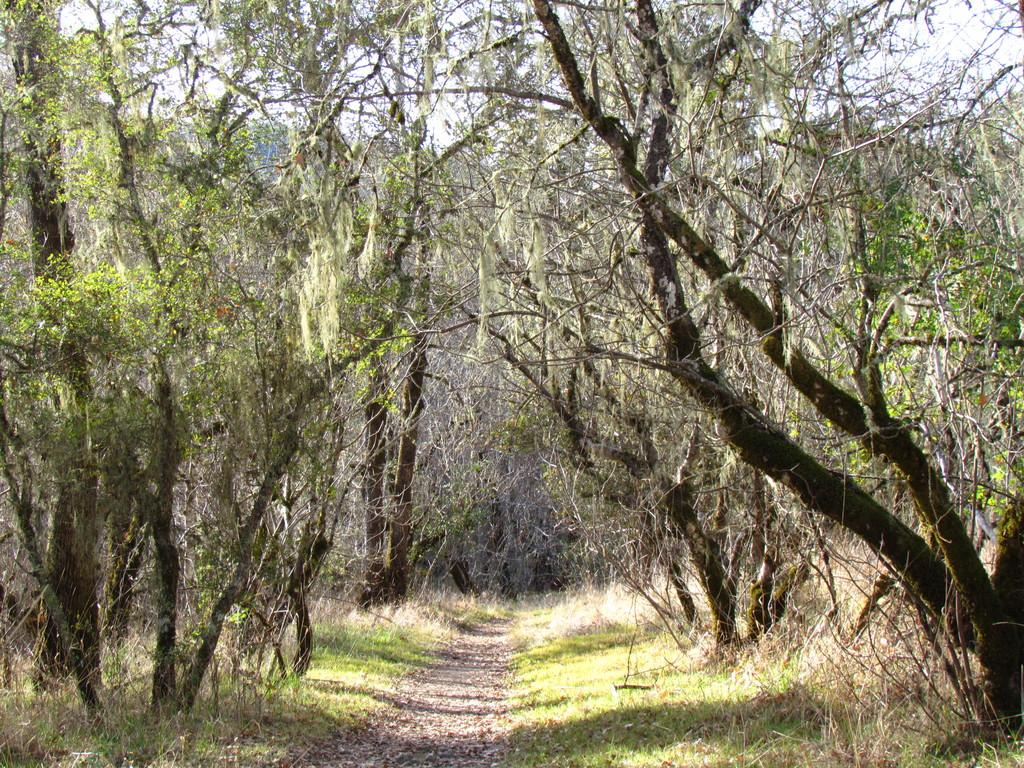What type of vegetation can be seen in the image? There are trees with branches and leaves in the image. What type of ground cover is visible in the image? There is grass visible in the image. Is there any indication of a path or trail in the image? Yes, there appears to be a pathway in the image. Can you describe the location depicted in the image? The location may be a forest, but this is not explicitly stated in the transcript. What is the condition of the yarn in the image? There is no yarn present in the image. What type of education is being provided in the image? There is no indication of any educational activity in the image. 